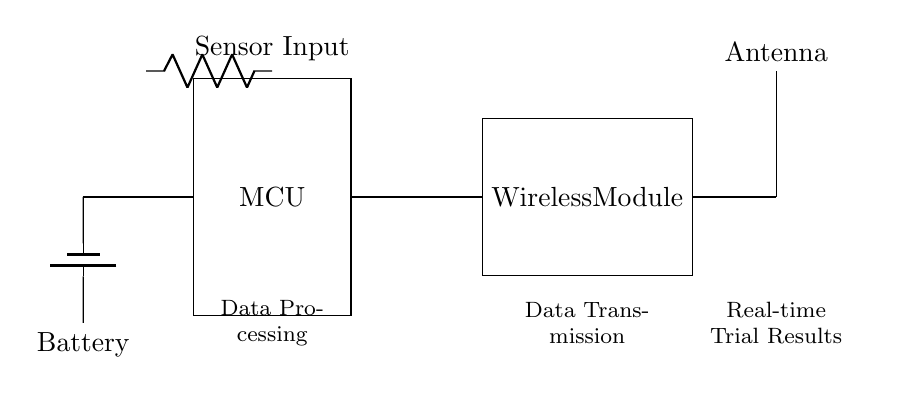What is the main function of the MCU? The MCU stands for Microcontroller Unit, which is primarily responsible for processing data received from the sensor input. It acts as the brain of the device, executing commands and managing the flow of information.
Answer: Data processing What is the role of the wireless module? The wireless module facilitates data transmission by encoding the processed data from the MCU and sending it wirelessly toward the antenna for real-time transmission of trial results.
Answer: Data transmission How many components are connected to the MCU? The MCU is connected to two components: the wireless module and the battery. These connections enable it to receive power and transmit data. Counting these provides a total connection of two components connected directly to the MCU.
Answer: Two What provides power to the circuit? The power source for this circuit is the battery, which supplies the necessary voltage to the Microcontroller Unit and other components to function properly within the circuit.
Answer: Battery What does the antenna transmit? The antenna transmits real-time trial results that have been processed and encoded by the wireless module, allowing the data to be sent wirelessly to a receiver.
Answer: Trial results Which component receives the sensor input? The component receiving the sensor input is depicted above the MCU with a resistor notation, indicating that this is where data from sensors enters the circuit for processing.
Answer: Sensor input 